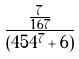Convert formula to latex. <formula><loc_0><loc_0><loc_500><loc_500>\frac { \frac { 7 } { 1 6 7 } } { ( 4 5 4 ^ { 7 } + 6 ) }</formula> 